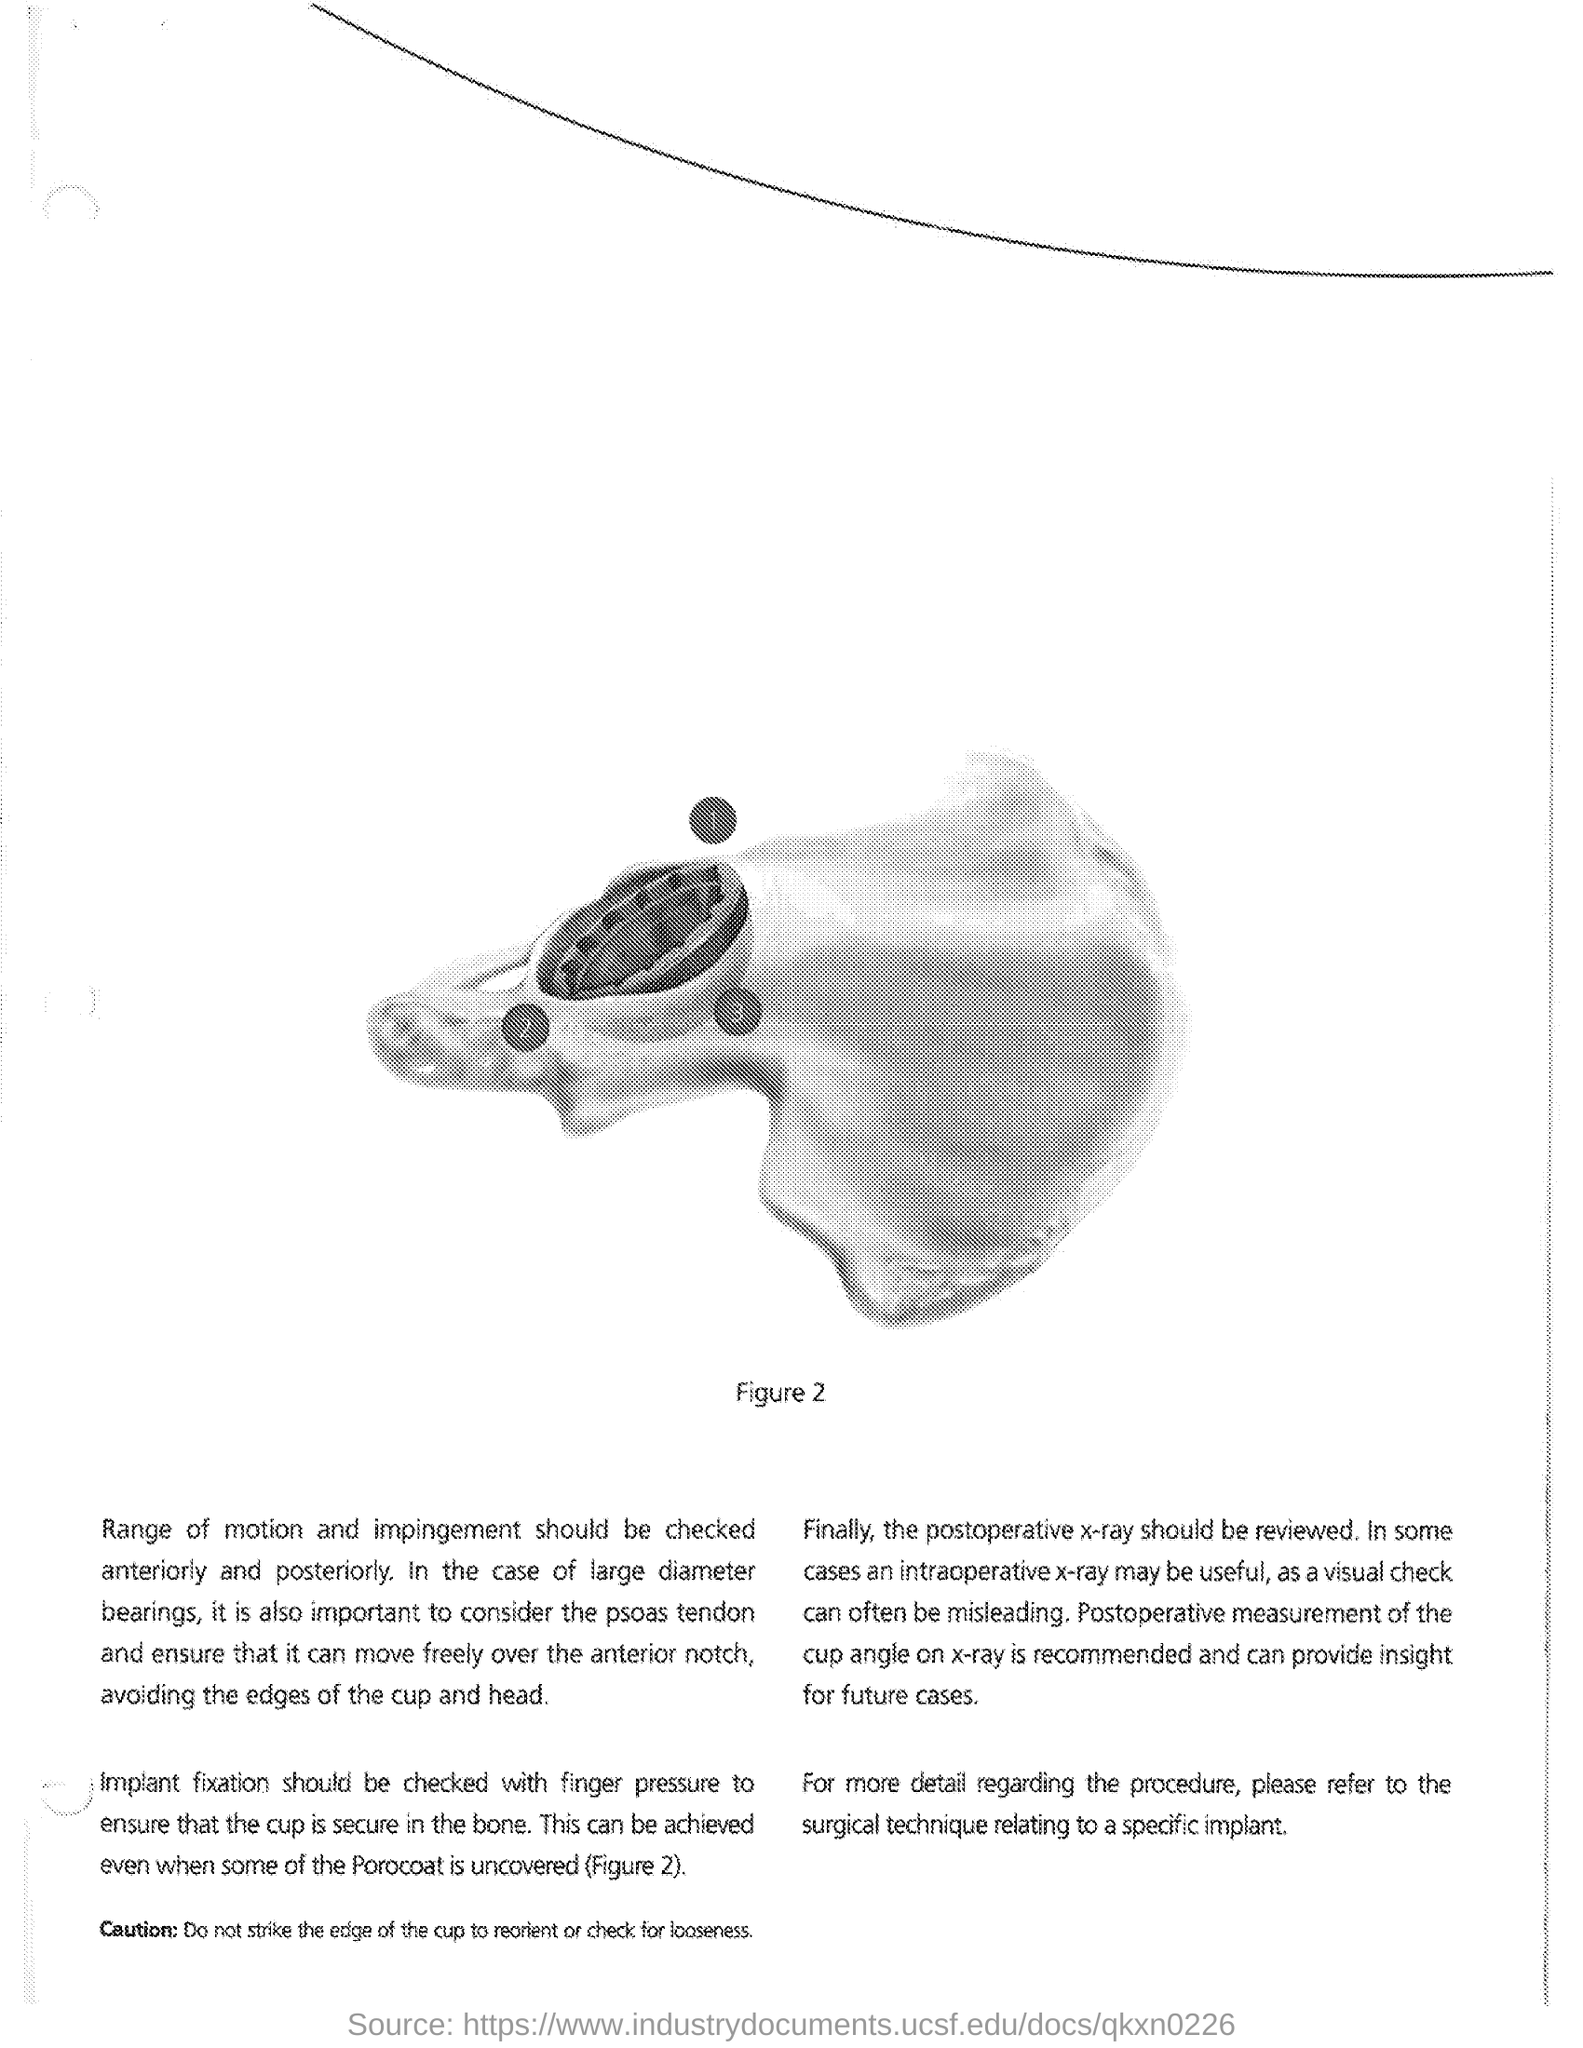What is the figure number?
Provide a short and direct response. 2. What should be refered for more details?
Keep it short and to the point. SURGICAL TECHNIQUE RELATING TO A SPECIFIC IMPLANT. What can provide insight for further cases?
Make the answer very short. Postoperative measurement of the cup angle on x-ray. How should the implant fixation be checked to ensure that the cup is secure in the bone?
Provide a short and direct response. Finger pressure. 